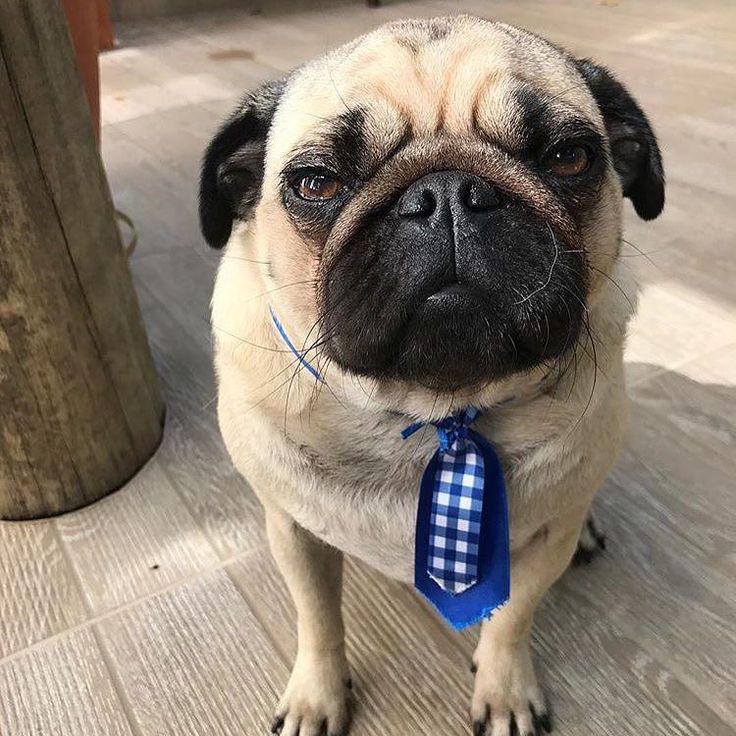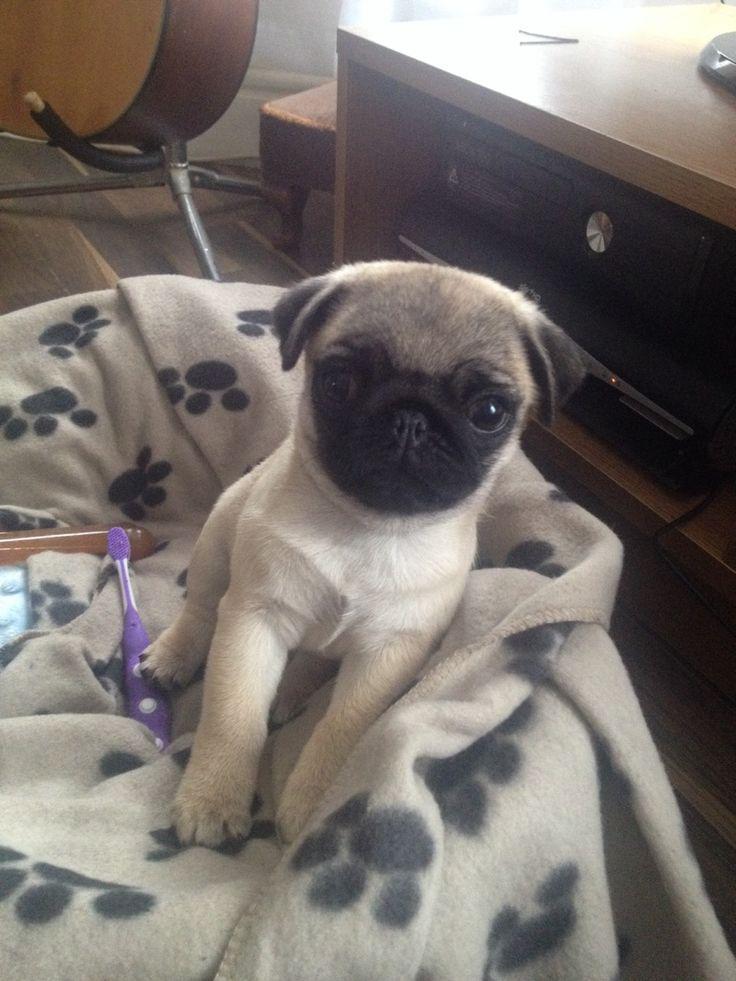The first image is the image on the left, the second image is the image on the right. Analyze the images presented: Is the assertion "One image shows a camera-facing sitting pug with something bright blue hanging downward from its neck." valid? Answer yes or no. Yes. The first image is the image on the left, the second image is the image on the right. Given the left and right images, does the statement "Only the dog in the image on the left is wearing a collar." hold true? Answer yes or no. Yes. 